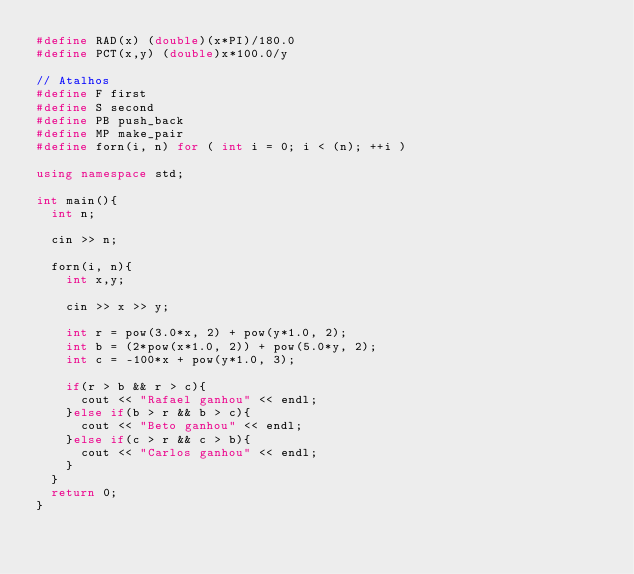Convert code to text. <code><loc_0><loc_0><loc_500><loc_500><_C++_>#define RAD(x) (double)(x*PI)/180.0
#define PCT(x,y) (double)x*100.0/y

// Atalhos
#define F first
#define S second
#define PB push_back
#define MP make_pair
#define forn(i, n) for ( int i = 0; i < (n); ++i )

using namespace std;

int main(){
	int n;

	cin >> n;

	forn(i, n){
		int x,y;

		cin >> x >> y;

		int r = pow(3.0*x, 2) + pow(y*1.0, 2);
		int b = (2*pow(x*1.0, 2)) + pow(5.0*y, 2);
		int c = -100*x + pow(y*1.0, 3);

		if(r > b && r > c){
			cout << "Rafael ganhou" << endl;
		}else if(b > r && b > c){
			cout << "Beto ganhou" << endl;
		}else if(c > r && c > b){
			cout << "Carlos ganhou" << endl;
		}
	}
	return 0;
}</code> 